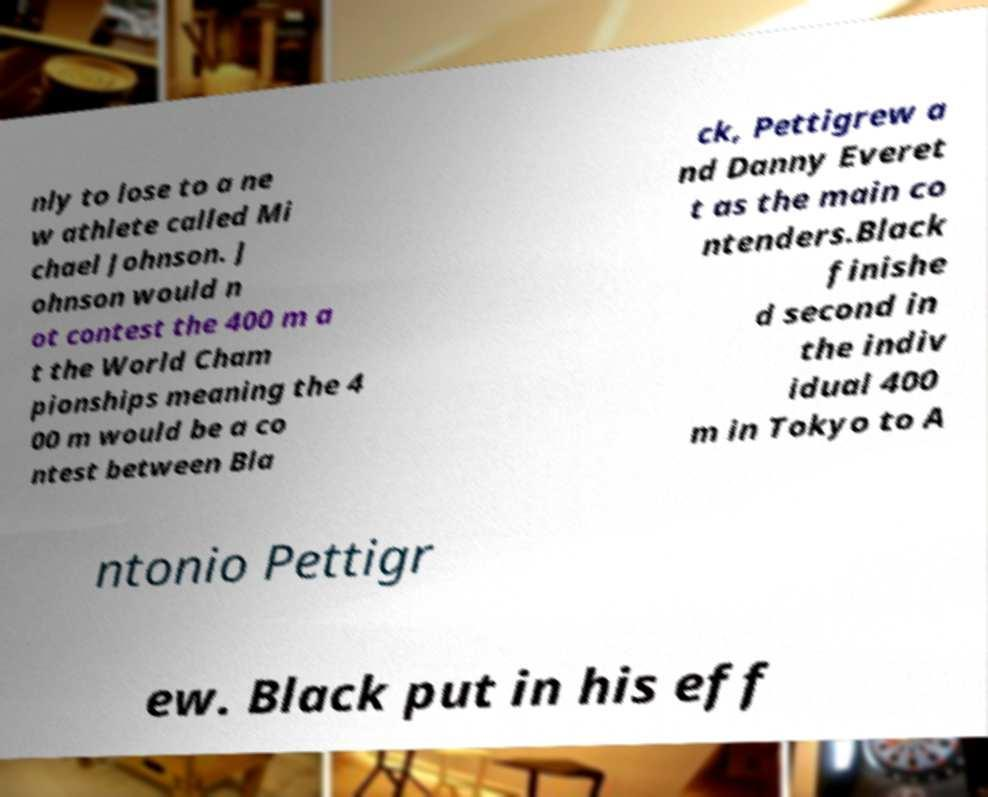Please read and relay the text visible in this image. What does it say? nly to lose to a ne w athlete called Mi chael Johnson. J ohnson would n ot contest the 400 m a t the World Cham pionships meaning the 4 00 m would be a co ntest between Bla ck, Pettigrew a nd Danny Everet t as the main co ntenders.Black finishe d second in the indiv idual 400 m in Tokyo to A ntonio Pettigr ew. Black put in his eff 